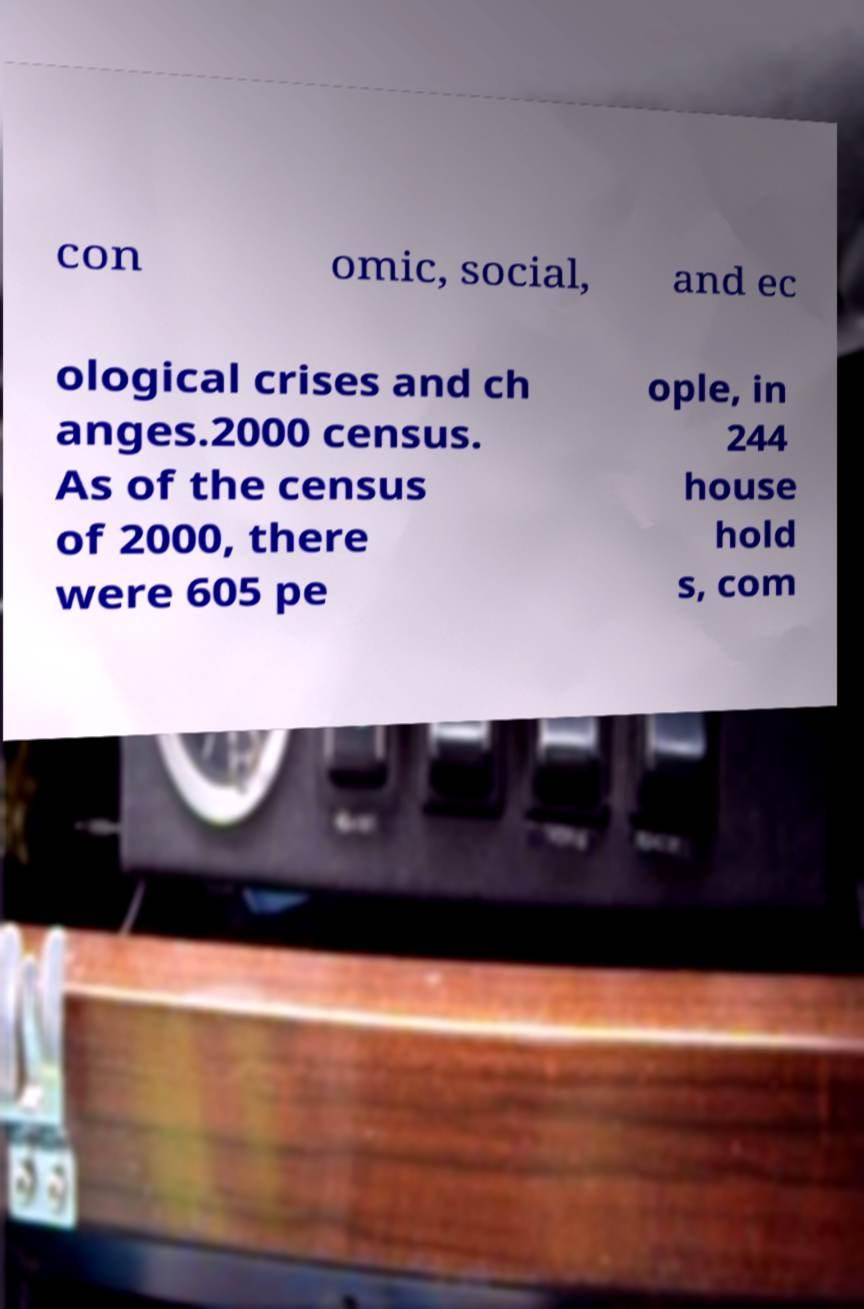Can you read and provide the text displayed in the image?This photo seems to have some interesting text. Can you extract and type it out for me? con omic, social, and ec ological crises and ch anges.2000 census. As of the census of 2000, there were 605 pe ople, in 244 house hold s, com 